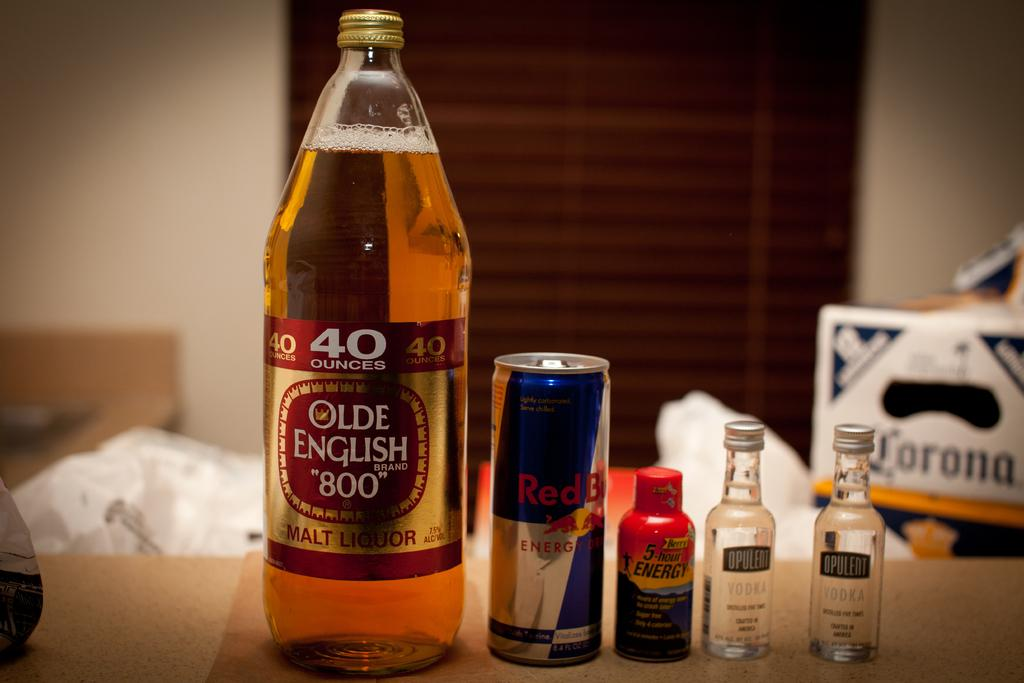<image>
Give a short and clear explanation of the subsequent image. a bottle of 40 ounces of olde english 800 on a counter next to some red bull 